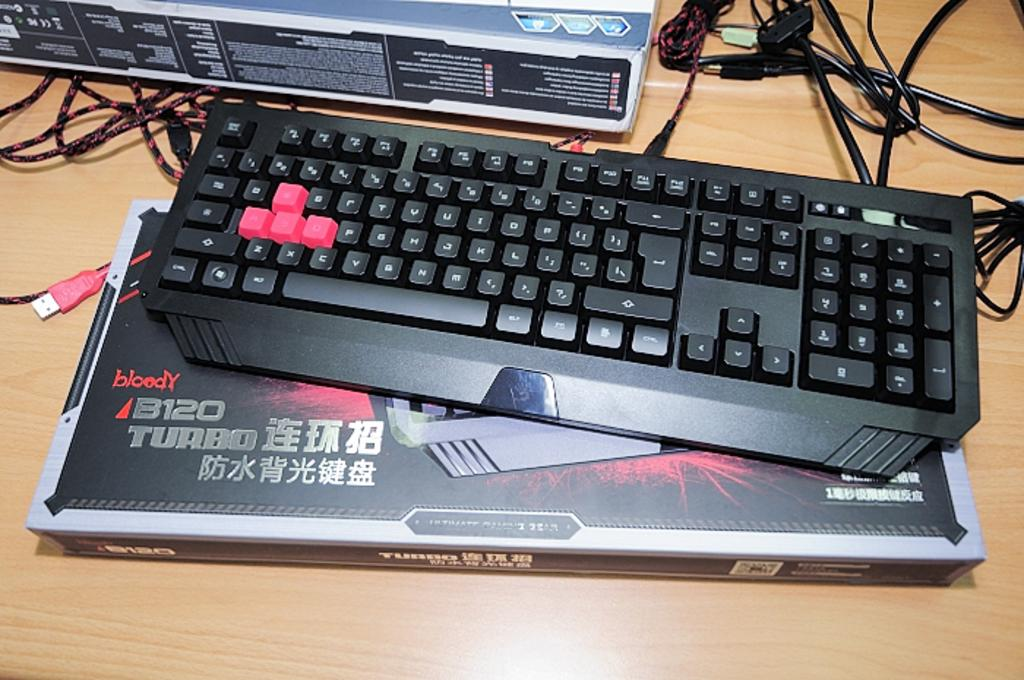<image>
Give a short and clear explanation of the subsequent image. A bloody B120 Turbo computer keyboard is seen here. 